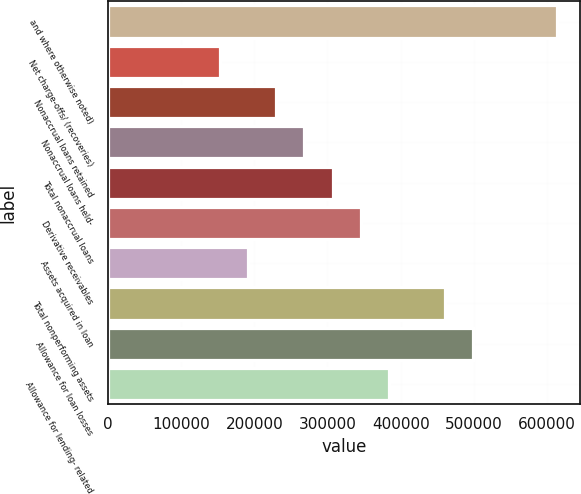Convert chart to OTSL. <chart><loc_0><loc_0><loc_500><loc_500><bar_chart><fcel>and where otherwise noted)<fcel>Net charge-offs/ (recoveries)<fcel>Nonaccrual loans retained<fcel>Nonaccrual loans held-<fcel>Total nonaccrual loans<fcel>Derivative receivables<fcel>Assets acquired in loan<fcel>Total nonperforming assets<fcel>Allowance for loan losses<fcel>Allowance for lending- related<nl><fcel>613867<fcel>153467<fcel>230200<fcel>268567<fcel>306934<fcel>345300<fcel>191834<fcel>460400<fcel>498767<fcel>383667<nl></chart> 